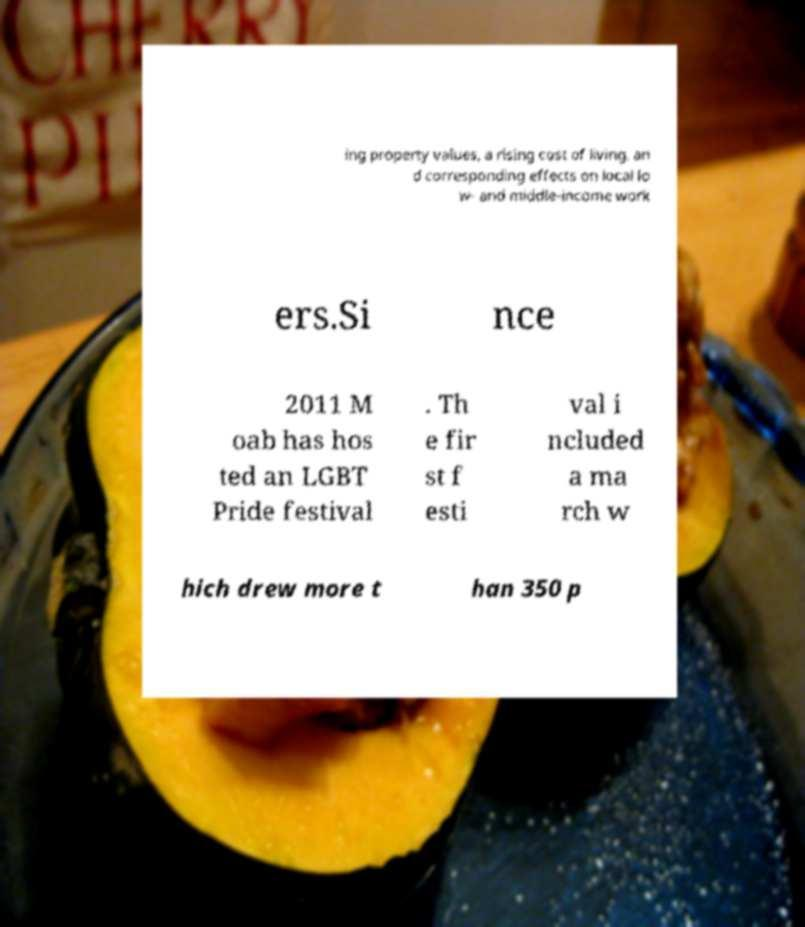I need the written content from this picture converted into text. Can you do that? ing property values, a rising cost of living, an d corresponding effects on local lo w- and middle-income work ers.Si nce 2011 M oab has hos ted an LGBT Pride festival . Th e fir st f esti val i ncluded a ma rch w hich drew more t han 350 p 